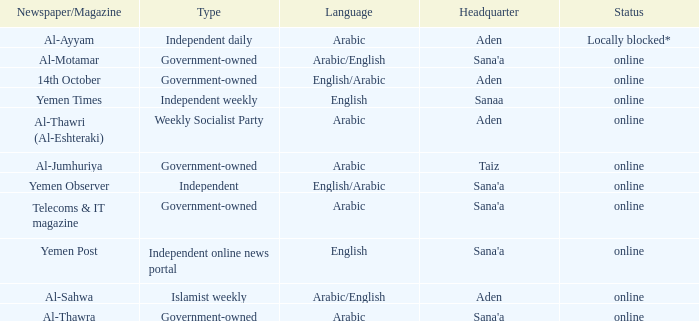What is Headquarter, when Type is Government-Owned, and when Newspaper/Magazine is Al-Jumhuriya? Taiz. 